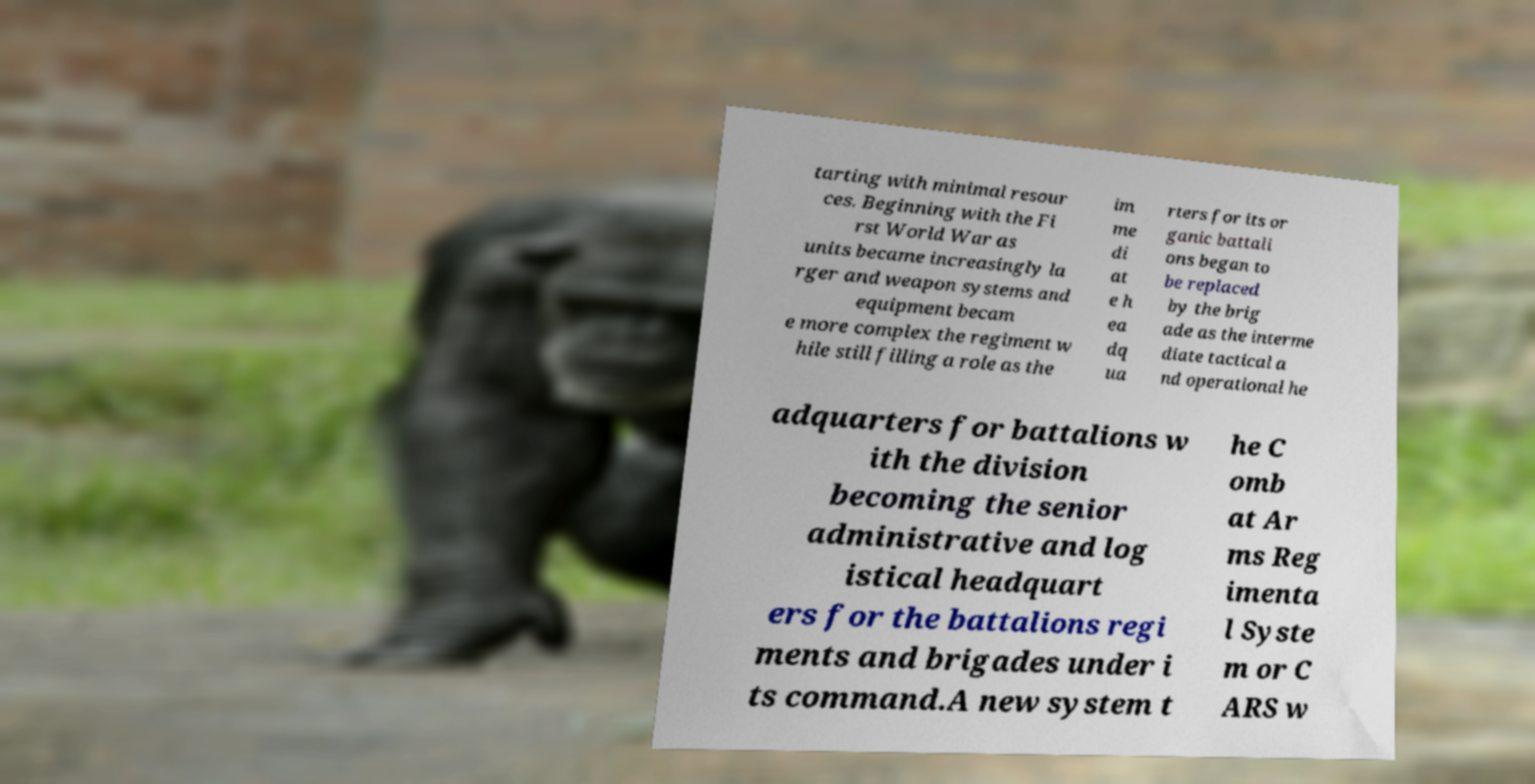I need the written content from this picture converted into text. Can you do that? tarting with minimal resour ces. Beginning with the Fi rst World War as units became increasingly la rger and weapon systems and equipment becam e more complex the regiment w hile still filling a role as the im me di at e h ea dq ua rters for its or ganic battali ons began to be replaced by the brig ade as the interme diate tactical a nd operational he adquarters for battalions w ith the division becoming the senior administrative and log istical headquart ers for the battalions regi ments and brigades under i ts command.A new system t he C omb at Ar ms Reg imenta l Syste m or C ARS w 